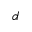<formula> <loc_0><loc_0><loc_500><loc_500>d</formula> 